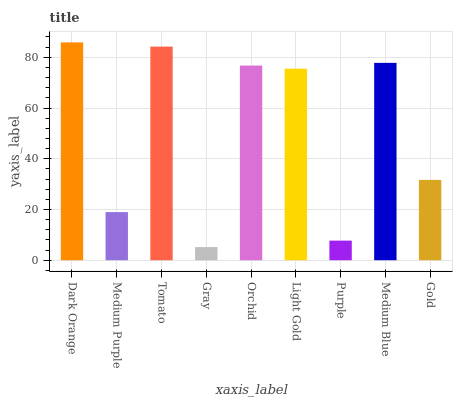Is Gray the minimum?
Answer yes or no. Yes. Is Dark Orange the maximum?
Answer yes or no. Yes. Is Medium Purple the minimum?
Answer yes or no. No. Is Medium Purple the maximum?
Answer yes or no. No. Is Dark Orange greater than Medium Purple?
Answer yes or no. Yes. Is Medium Purple less than Dark Orange?
Answer yes or no. Yes. Is Medium Purple greater than Dark Orange?
Answer yes or no. No. Is Dark Orange less than Medium Purple?
Answer yes or no. No. Is Light Gold the high median?
Answer yes or no. Yes. Is Light Gold the low median?
Answer yes or no. Yes. Is Gold the high median?
Answer yes or no. No. Is Gold the low median?
Answer yes or no. No. 